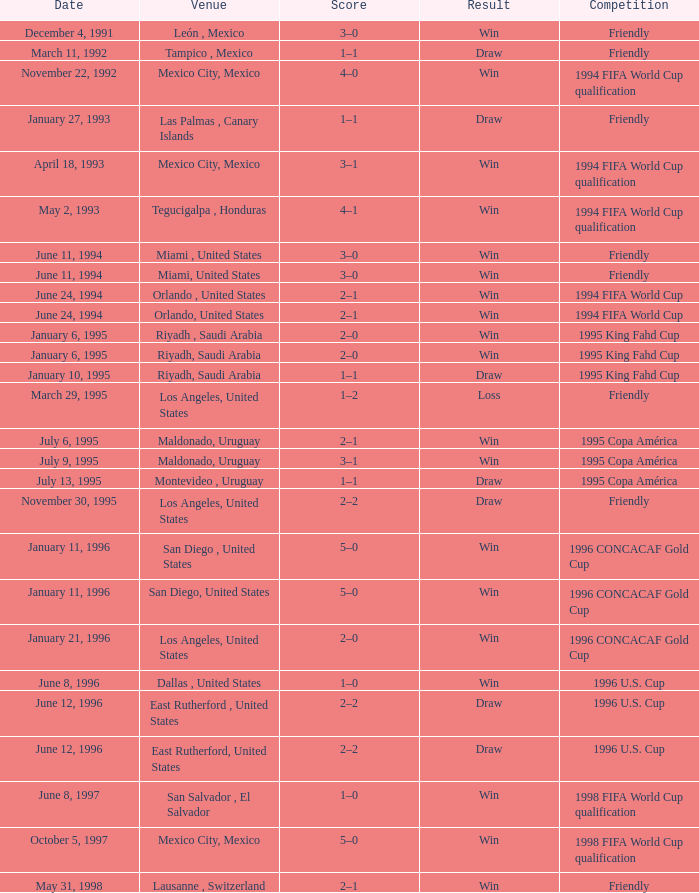What is the location when the date is "january 6, 1995"? Riyadh , Saudi Arabia, Riyadh, Saudi Arabia. 